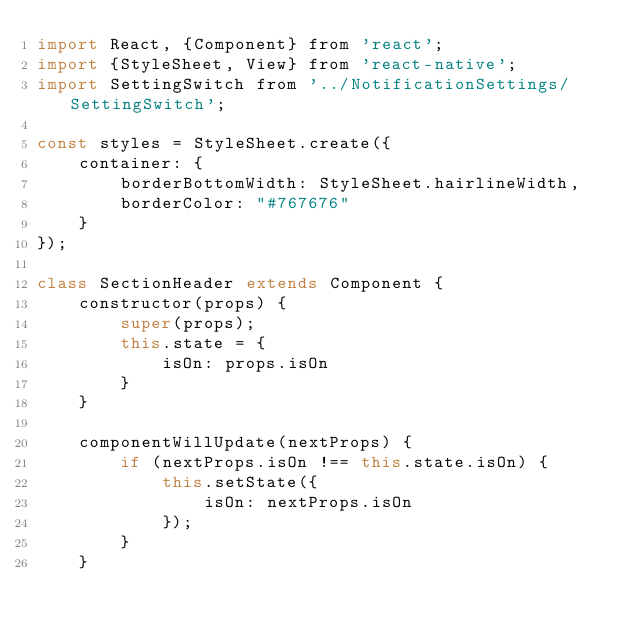<code> <loc_0><loc_0><loc_500><loc_500><_JavaScript_>import React, {Component} from 'react';
import {StyleSheet, View} from 'react-native';
import SettingSwitch from '../NotificationSettings/SettingSwitch';

const styles = StyleSheet.create({
	container: {
		borderBottomWidth: StyleSheet.hairlineWidth,
		borderColor: "#767676"
	}
});

class SectionHeader extends Component {
	constructor(props) {
		super(props);
		this.state = {
			isOn: props.isOn
		}
	}

	componentWillUpdate(nextProps) {
		if (nextProps.isOn !== this.state.isOn) {
			this.setState({
				isOn: nextProps.isOn
			});
		}
	}
</code> 